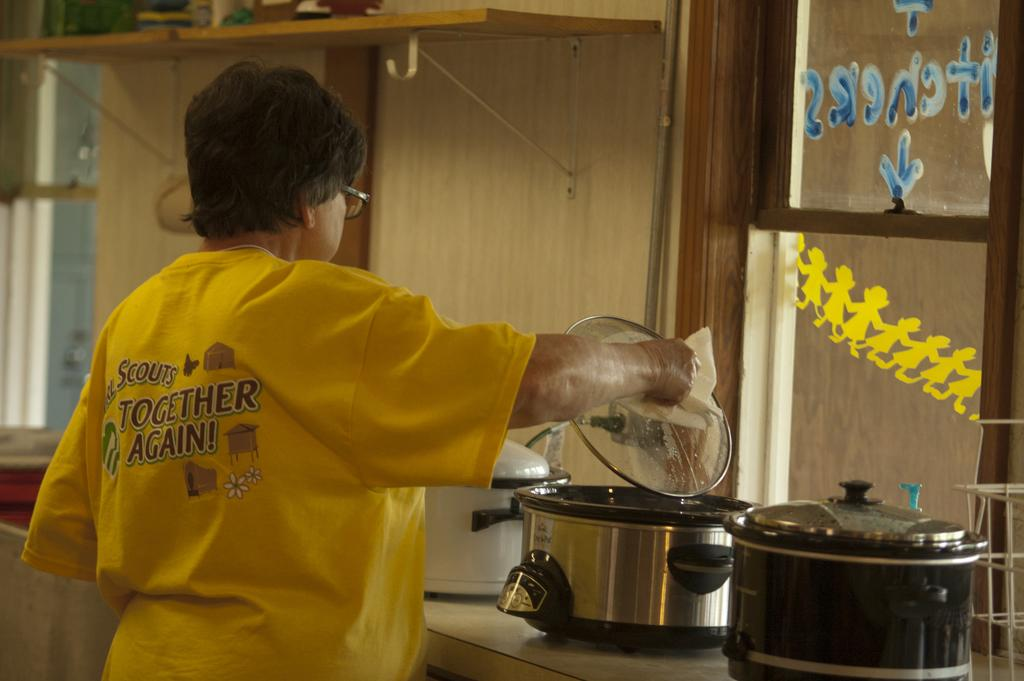<image>
Render a clear and concise summary of the photo. A person opening a lid on a slow cooker wearing a yellow T-shirt that says Together Again. 